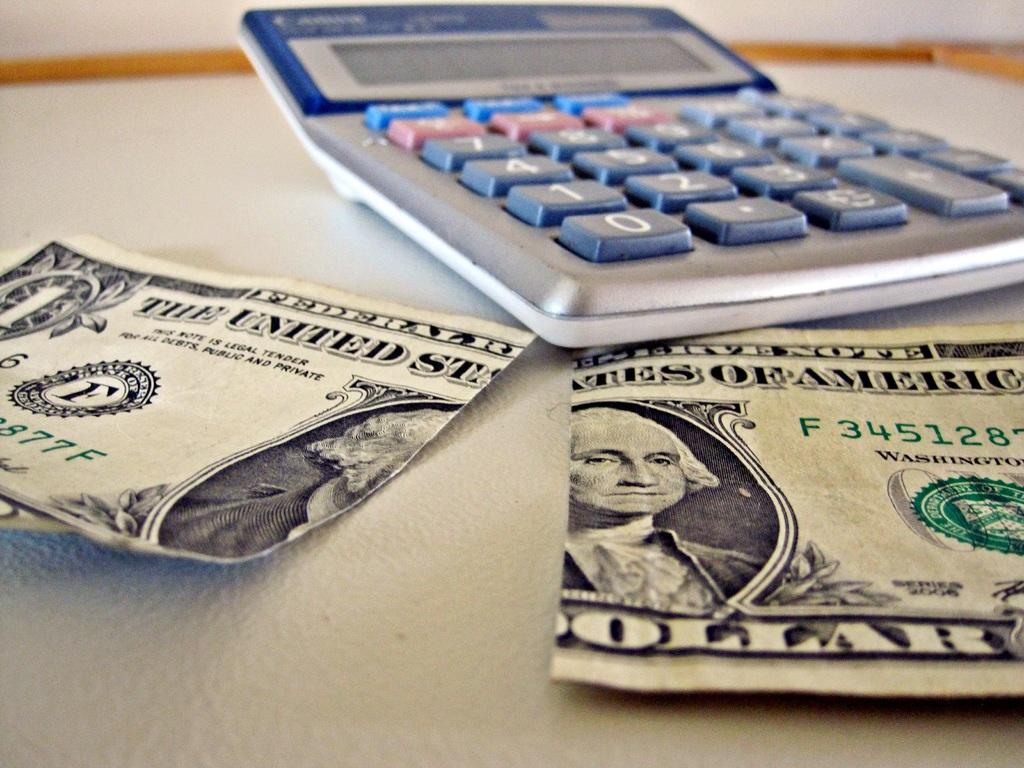<image>
Provide a brief description of the given image. A dollar bill is split in half through the word "States". 